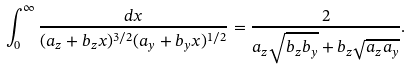<formula> <loc_0><loc_0><loc_500><loc_500>\int _ { 0 } ^ { \infty } \frac { d x } { ( a _ { z } + b _ { z } x ) ^ { 3 / 2 } ( a _ { y } + b _ { y } x ) ^ { 1 / 2 } } = \frac { 2 } { a _ { z } \sqrt { b _ { z } b _ { y } } + b _ { z } \sqrt { a _ { z } a _ { y } } } .</formula> 